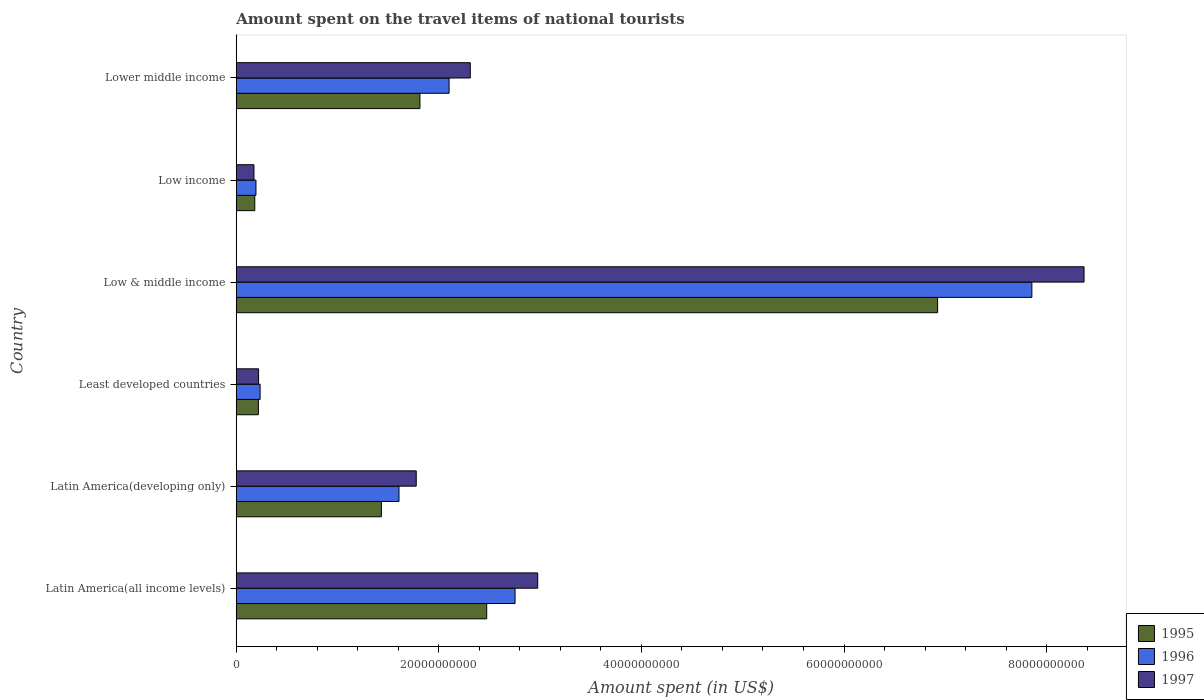Are the number of bars per tick equal to the number of legend labels?
Provide a succinct answer. Yes. Are the number of bars on each tick of the Y-axis equal?
Your answer should be compact. Yes. How many bars are there on the 6th tick from the top?
Provide a succinct answer. 3. How many bars are there on the 2nd tick from the bottom?
Your answer should be compact. 3. What is the label of the 1st group of bars from the top?
Your answer should be compact. Lower middle income. In how many cases, is the number of bars for a given country not equal to the number of legend labels?
Ensure brevity in your answer.  0. What is the amount spent on the travel items of national tourists in 1995 in Latin America(developing only)?
Ensure brevity in your answer.  1.43e+1. Across all countries, what is the maximum amount spent on the travel items of national tourists in 1996?
Provide a succinct answer. 7.85e+1. Across all countries, what is the minimum amount spent on the travel items of national tourists in 1996?
Provide a succinct answer. 1.94e+09. In which country was the amount spent on the travel items of national tourists in 1997 minimum?
Your answer should be compact. Low income. What is the total amount spent on the travel items of national tourists in 1996 in the graph?
Provide a short and direct response. 1.47e+11. What is the difference between the amount spent on the travel items of national tourists in 1995 in Latin America(developing only) and that in Lower middle income?
Make the answer very short. -3.81e+09. What is the difference between the amount spent on the travel items of national tourists in 1997 in Latin America(all income levels) and the amount spent on the travel items of national tourists in 1995 in Low & middle income?
Make the answer very short. -3.95e+1. What is the average amount spent on the travel items of national tourists in 1995 per country?
Give a very brief answer. 2.17e+1. What is the difference between the amount spent on the travel items of national tourists in 1996 and amount spent on the travel items of national tourists in 1995 in Low income?
Your answer should be compact. 1.15e+08. In how many countries, is the amount spent on the travel items of national tourists in 1995 greater than 24000000000 US$?
Your response must be concise. 2. What is the ratio of the amount spent on the travel items of national tourists in 1995 in Low & middle income to that in Lower middle income?
Your answer should be compact. 3.82. Is the amount spent on the travel items of national tourists in 1996 in Latin America(all income levels) less than that in Latin America(developing only)?
Give a very brief answer. No. What is the difference between the highest and the second highest amount spent on the travel items of national tourists in 1996?
Offer a terse response. 5.10e+1. What is the difference between the highest and the lowest amount spent on the travel items of national tourists in 1996?
Your answer should be compact. 7.66e+1. How many bars are there?
Your response must be concise. 18. Are the values on the major ticks of X-axis written in scientific E-notation?
Offer a very short reply. No. Does the graph contain any zero values?
Your answer should be very brief. No. How many legend labels are there?
Keep it short and to the point. 3. How are the legend labels stacked?
Provide a short and direct response. Vertical. What is the title of the graph?
Provide a short and direct response. Amount spent on the travel items of national tourists. Does "1979" appear as one of the legend labels in the graph?
Ensure brevity in your answer.  No. What is the label or title of the X-axis?
Your answer should be very brief. Amount spent (in US$). What is the Amount spent (in US$) in 1995 in Latin America(all income levels)?
Make the answer very short. 2.47e+1. What is the Amount spent (in US$) of 1996 in Latin America(all income levels)?
Provide a short and direct response. 2.75e+1. What is the Amount spent (in US$) of 1997 in Latin America(all income levels)?
Give a very brief answer. 2.98e+1. What is the Amount spent (in US$) in 1995 in Latin America(developing only)?
Offer a very short reply. 1.43e+1. What is the Amount spent (in US$) in 1996 in Latin America(developing only)?
Offer a very short reply. 1.61e+1. What is the Amount spent (in US$) of 1997 in Latin America(developing only)?
Your answer should be compact. 1.78e+1. What is the Amount spent (in US$) in 1995 in Least developed countries?
Offer a terse response. 2.19e+09. What is the Amount spent (in US$) in 1996 in Least developed countries?
Offer a terse response. 2.36e+09. What is the Amount spent (in US$) in 1997 in Least developed countries?
Ensure brevity in your answer.  2.20e+09. What is the Amount spent (in US$) of 1995 in Low & middle income?
Your answer should be very brief. 6.92e+1. What is the Amount spent (in US$) of 1996 in Low & middle income?
Your response must be concise. 7.85e+1. What is the Amount spent (in US$) in 1997 in Low & middle income?
Provide a succinct answer. 8.37e+1. What is the Amount spent (in US$) in 1995 in Low income?
Ensure brevity in your answer.  1.83e+09. What is the Amount spent (in US$) of 1996 in Low income?
Keep it short and to the point. 1.94e+09. What is the Amount spent (in US$) of 1997 in Low income?
Your answer should be very brief. 1.75e+09. What is the Amount spent (in US$) of 1995 in Lower middle income?
Make the answer very short. 1.81e+1. What is the Amount spent (in US$) in 1996 in Lower middle income?
Your response must be concise. 2.10e+1. What is the Amount spent (in US$) of 1997 in Lower middle income?
Your response must be concise. 2.31e+1. Across all countries, what is the maximum Amount spent (in US$) of 1995?
Provide a succinct answer. 6.92e+1. Across all countries, what is the maximum Amount spent (in US$) of 1996?
Give a very brief answer. 7.85e+1. Across all countries, what is the maximum Amount spent (in US$) of 1997?
Provide a short and direct response. 8.37e+1. Across all countries, what is the minimum Amount spent (in US$) in 1995?
Keep it short and to the point. 1.83e+09. Across all countries, what is the minimum Amount spent (in US$) in 1996?
Provide a succinct answer. 1.94e+09. Across all countries, what is the minimum Amount spent (in US$) of 1997?
Offer a terse response. 1.75e+09. What is the total Amount spent (in US$) of 1995 in the graph?
Your response must be concise. 1.30e+11. What is the total Amount spent (in US$) of 1996 in the graph?
Offer a very short reply. 1.47e+11. What is the total Amount spent (in US$) in 1997 in the graph?
Provide a succinct answer. 1.58e+11. What is the difference between the Amount spent (in US$) in 1995 in Latin America(all income levels) and that in Latin America(developing only)?
Offer a very short reply. 1.04e+1. What is the difference between the Amount spent (in US$) in 1996 in Latin America(all income levels) and that in Latin America(developing only)?
Make the answer very short. 1.15e+1. What is the difference between the Amount spent (in US$) of 1997 in Latin America(all income levels) and that in Latin America(developing only)?
Keep it short and to the point. 1.20e+1. What is the difference between the Amount spent (in US$) of 1995 in Latin America(all income levels) and that in Least developed countries?
Your answer should be very brief. 2.25e+1. What is the difference between the Amount spent (in US$) of 1996 in Latin America(all income levels) and that in Least developed countries?
Your answer should be very brief. 2.52e+1. What is the difference between the Amount spent (in US$) of 1997 in Latin America(all income levels) and that in Least developed countries?
Give a very brief answer. 2.76e+1. What is the difference between the Amount spent (in US$) in 1995 in Latin America(all income levels) and that in Low & middle income?
Ensure brevity in your answer.  -4.45e+1. What is the difference between the Amount spent (in US$) of 1996 in Latin America(all income levels) and that in Low & middle income?
Provide a short and direct response. -5.10e+1. What is the difference between the Amount spent (in US$) in 1997 in Latin America(all income levels) and that in Low & middle income?
Make the answer very short. -5.39e+1. What is the difference between the Amount spent (in US$) in 1995 in Latin America(all income levels) and that in Low income?
Give a very brief answer. 2.29e+1. What is the difference between the Amount spent (in US$) in 1996 in Latin America(all income levels) and that in Low income?
Offer a terse response. 2.56e+1. What is the difference between the Amount spent (in US$) of 1997 in Latin America(all income levels) and that in Low income?
Provide a succinct answer. 2.80e+1. What is the difference between the Amount spent (in US$) of 1995 in Latin America(all income levels) and that in Lower middle income?
Keep it short and to the point. 6.59e+09. What is the difference between the Amount spent (in US$) in 1996 in Latin America(all income levels) and that in Lower middle income?
Your answer should be very brief. 6.51e+09. What is the difference between the Amount spent (in US$) of 1997 in Latin America(all income levels) and that in Lower middle income?
Give a very brief answer. 6.66e+09. What is the difference between the Amount spent (in US$) in 1995 in Latin America(developing only) and that in Least developed countries?
Your response must be concise. 1.21e+1. What is the difference between the Amount spent (in US$) of 1996 in Latin America(developing only) and that in Least developed countries?
Provide a succinct answer. 1.37e+1. What is the difference between the Amount spent (in US$) in 1997 in Latin America(developing only) and that in Least developed countries?
Offer a very short reply. 1.56e+1. What is the difference between the Amount spent (in US$) of 1995 in Latin America(developing only) and that in Low & middle income?
Provide a short and direct response. -5.49e+1. What is the difference between the Amount spent (in US$) in 1996 in Latin America(developing only) and that in Low & middle income?
Offer a terse response. -6.25e+1. What is the difference between the Amount spent (in US$) in 1997 in Latin America(developing only) and that in Low & middle income?
Make the answer very short. -6.59e+1. What is the difference between the Amount spent (in US$) in 1995 in Latin America(developing only) and that in Low income?
Offer a very short reply. 1.25e+1. What is the difference between the Amount spent (in US$) of 1996 in Latin America(developing only) and that in Low income?
Your answer should be compact. 1.41e+1. What is the difference between the Amount spent (in US$) of 1997 in Latin America(developing only) and that in Low income?
Ensure brevity in your answer.  1.60e+1. What is the difference between the Amount spent (in US$) of 1995 in Latin America(developing only) and that in Lower middle income?
Provide a succinct answer. -3.81e+09. What is the difference between the Amount spent (in US$) of 1996 in Latin America(developing only) and that in Lower middle income?
Provide a short and direct response. -4.95e+09. What is the difference between the Amount spent (in US$) in 1997 in Latin America(developing only) and that in Lower middle income?
Make the answer very short. -5.34e+09. What is the difference between the Amount spent (in US$) in 1995 in Least developed countries and that in Low & middle income?
Your response must be concise. -6.71e+1. What is the difference between the Amount spent (in US$) of 1996 in Least developed countries and that in Low & middle income?
Give a very brief answer. -7.62e+1. What is the difference between the Amount spent (in US$) in 1997 in Least developed countries and that in Low & middle income?
Keep it short and to the point. -8.15e+1. What is the difference between the Amount spent (in US$) in 1995 in Least developed countries and that in Low income?
Make the answer very short. 3.56e+08. What is the difference between the Amount spent (in US$) of 1996 in Least developed countries and that in Low income?
Your answer should be very brief. 4.11e+08. What is the difference between the Amount spent (in US$) in 1997 in Least developed countries and that in Low income?
Your response must be concise. 4.55e+08. What is the difference between the Amount spent (in US$) of 1995 in Least developed countries and that in Lower middle income?
Offer a very short reply. -1.59e+1. What is the difference between the Amount spent (in US$) in 1996 in Least developed countries and that in Lower middle income?
Provide a succinct answer. -1.87e+1. What is the difference between the Amount spent (in US$) of 1997 in Least developed countries and that in Lower middle income?
Offer a very short reply. -2.09e+1. What is the difference between the Amount spent (in US$) of 1995 in Low & middle income and that in Low income?
Your answer should be very brief. 6.74e+1. What is the difference between the Amount spent (in US$) of 1996 in Low & middle income and that in Low income?
Provide a short and direct response. 7.66e+1. What is the difference between the Amount spent (in US$) of 1997 in Low & middle income and that in Low income?
Your answer should be very brief. 8.19e+1. What is the difference between the Amount spent (in US$) of 1995 in Low & middle income and that in Lower middle income?
Make the answer very short. 5.11e+1. What is the difference between the Amount spent (in US$) of 1996 in Low & middle income and that in Lower middle income?
Provide a short and direct response. 5.75e+1. What is the difference between the Amount spent (in US$) of 1997 in Low & middle income and that in Lower middle income?
Give a very brief answer. 6.06e+1. What is the difference between the Amount spent (in US$) of 1995 in Low income and that in Lower middle income?
Your response must be concise. -1.63e+1. What is the difference between the Amount spent (in US$) of 1996 in Low income and that in Lower middle income?
Keep it short and to the point. -1.91e+1. What is the difference between the Amount spent (in US$) of 1997 in Low income and that in Lower middle income?
Provide a succinct answer. -2.14e+1. What is the difference between the Amount spent (in US$) of 1995 in Latin America(all income levels) and the Amount spent (in US$) of 1996 in Latin America(developing only)?
Provide a succinct answer. 8.66e+09. What is the difference between the Amount spent (in US$) in 1995 in Latin America(all income levels) and the Amount spent (in US$) in 1997 in Latin America(developing only)?
Keep it short and to the point. 6.96e+09. What is the difference between the Amount spent (in US$) of 1996 in Latin America(all income levels) and the Amount spent (in US$) of 1997 in Latin America(developing only)?
Give a very brief answer. 9.76e+09. What is the difference between the Amount spent (in US$) in 1995 in Latin America(all income levels) and the Amount spent (in US$) in 1996 in Least developed countries?
Ensure brevity in your answer.  2.24e+1. What is the difference between the Amount spent (in US$) of 1995 in Latin America(all income levels) and the Amount spent (in US$) of 1997 in Least developed countries?
Give a very brief answer. 2.25e+1. What is the difference between the Amount spent (in US$) in 1996 in Latin America(all income levels) and the Amount spent (in US$) in 1997 in Least developed countries?
Make the answer very short. 2.53e+1. What is the difference between the Amount spent (in US$) of 1995 in Latin America(all income levels) and the Amount spent (in US$) of 1996 in Low & middle income?
Provide a succinct answer. -5.38e+1. What is the difference between the Amount spent (in US$) in 1995 in Latin America(all income levels) and the Amount spent (in US$) in 1997 in Low & middle income?
Offer a terse response. -5.90e+1. What is the difference between the Amount spent (in US$) in 1996 in Latin America(all income levels) and the Amount spent (in US$) in 1997 in Low & middle income?
Give a very brief answer. -5.62e+1. What is the difference between the Amount spent (in US$) of 1995 in Latin America(all income levels) and the Amount spent (in US$) of 1996 in Low income?
Make the answer very short. 2.28e+1. What is the difference between the Amount spent (in US$) in 1995 in Latin America(all income levels) and the Amount spent (in US$) in 1997 in Low income?
Give a very brief answer. 2.30e+1. What is the difference between the Amount spent (in US$) of 1996 in Latin America(all income levels) and the Amount spent (in US$) of 1997 in Low income?
Keep it short and to the point. 2.58e+1. What is the difference between the Amount spent (in US$) in 1995 in Latin America(all income levels) and the Amount spent (in US$) in 1996 in Lower middle income?
Ensure brevity in your answer.  3.71e+09. What is the difference between the Amount spent (in US$) in 1995 in Latin America(all income levels) and the Amount spent (in US$) in 1997 in Lower middle income?
Provide a succinct answer. 1.62e+09. What is the difference between the Amount spent (in US$) of 1996 in Latin America(all income levels) and the Amount spent (in US$) of 1997 in Lower middle income?
Provide a short and direct response. 4.42e+09. What is the difference between the Amount spent (in US$) of 1995 in Latin America(developing only) and the Amount spent (in US$) of 1996 in Least developed countries?
Provide a short and direct response. 1.20e+1. What is the difference between the Amount spent (in US$) in 1995 in Latin America(developing only) and the Amount spent (in US$) in 1997 in Least developed countries?
Your answer should be very brief. 1.21e+1. What is the difference between the Amount spent (in US$) in 1996 in Latin America(developing only) and the Amount spent (in US$) in 1997 in Least developed countries?
Your response must be concise. 1.39e+1. What is the difference between the Amount spent (in US$) in 1995 in Latin America(developing only) and the Amount spent (in US$) in 1996 in Low & middle income?
Your answer should be compact. -6.42e+1. What is the difference between the Amount spent (in US$) in 1995 in Latin America(developing only) and the Amount spent (in US$) in 1997 in Low & middle income?
Keep it short and to the point. -6.94e+1. What is the difference between the Amount spent (in US$) in 1996 in Latin America(developing only) and the Amount spent (in US$) in 1997 in Low & middle income?
Offer a terse response. -6.76e+1. What is the difference between the Amount spent (in US$) of 1995 in Latin America(developing only) and the Amount spent (in US$) of 1996 in Low income?
Keep it short and to the point. 1.24e+1. What is the difference between the Amount spent (in US$) of 1995 in Latin America(developing only) and the Amount spent (in US$) of 1997 in Low income?
Your answer should be very brief. 1.26e+1. What is the difference between the Amount spent (in US$) of 1996 in Latin America(developing only) and the Amount spent (in US$) of 1997 in Low income?
Your answer should be very brief. 1.43e+1. What is the difference between the Amount spent (in US$) in 1995 in Latin America(developing only) and the Amount spent (in US$) in 1996 in Lower middle income?
Your response must be concise. -6.69e+09. What is the difference between the Amount spent (in US$) of 1995 in Latin America(developing only) and the Amount spent (in US$) of 1997 in Lower middle income?
Ensure brevity in your answer.  -8.78e+09. What is the difference between the Amount spent (in US$) in 1996 in Latin America(developing only) and the Amount spent (in US$) in 1997 in Lower middle income?
Keep it short and to the point. -7.04e+09. What is the difference between the Amount spent (in US$) in 1995 in Least developed countries and the Amount spent (in US$) in 1996 in Low & middle income?
Provide a short and direct response. -7.64e+1. What is the difference between the Amount spent (in US$) in 1995 in Least developed countries and the Amount spent (in US$) in 1997 in Low & middle income?
Give a very brief answer. -8.15e+1. What is the difference between the Amount spent (in US$) in 1996 in Least developed countries and the Amount spent (in US$) in 1997 in Low & middle income?
Your answer should be very brief. -8.13e+1. What is the difference between the Amount spent (in US$) in 1995 in Least developed countries and the Amount spent (in US$) in 1996 in Low income?
Give a very brief answer. 2.41e+08. What is the difference between the Amount spent (in US$) of 1995 in Least developed countries and the Amount spent (in US$) of 1997 in Low income?
Provide a short and direct response. 4.37e+08. What is the difference between the Amount spent (in US$) in 1996 in Least developed countries and the Amount spent (in US$) in 1997 in Low income?
Your answer should be compact. 6.07e+08. What is the difference between the Amount spent (in US$) in 1995 in Least developed countries and the Amount spent (in US$) in 1996 in Lower middle income?
Offer a terse response. -1.88e+1. What is the difference between the Amount spent (in US$) of 1995 in Least developed countries and the Amount spent (in US$) of 1997 in Lower middle income?
Make the answer very short. -2.09e+1. What is the difference between the Amount spent (in US$) of 1996 in Least developed countries and the Amount spent (in US$) of 1997 in Lower middle income?
Keep it short and to the point. -2.07e+1. What is the difference between the Amount spent (in US$) in 1995 in Low & middle income and the Amount spent (in US$) in 1996 in Low income?
Your answer should be very brief. 6.73e+1. What is the difference between the Amount spent (in US$) in 1995 in Low & middle income and the Amount spent (in US$) in 1997 in Low income?
Your answer should be compact. 6.75e+1. What is the difference between the Amount spent (in US$) of 1996 in Low & middle income and the Amount spent (in US$) of 1997 in Low income?
Make the answer very short. 7.68e+1. What is the difference between the Amount spent (in US$) of 1995 in Low & middle income and the Amount spent (in US$) of 1996 in Lower middle income?
Your answer should be very brief. 4.82e+1. What is the difference between the Amount spent (in US$) in 1995 in Low & middle income and the Amount spent (in US$) in 1997 in Lower middle income?
Keep it short and to the point. 4.61e+1. What is the difference between the Amount spent (in US$) in 1996 in Low & middle income and the Amount spent (in US$) in 1997 in Lower middle income?
Your answer should be very brief. 5.54e+1. What is the difference between the Amount spent (in US$) in 1995 in Low income and the Amount spent (in US$) in 1996 in Lower middle income?
Your answer should be very brief. -1.92e+1. What is the difference between the Amount spent (in US$) in 1995 in Low income and the Amount spent (in US$) in 1997 in Lower middle income?
Give a very brief answer. -2.13e+1. What is the difference between the Amount spent (in US$) of 1996 in Low income and the Amount spent (in US$) of 1997 in Lower middle income?
Your answer should be compact. -2.12e+1. What is the average Amount spent (in US$) of 1995 per country?
Provide a succinct answer. 2.17e+1. What is the average Amount spent (in US$) in 1996 per country?
Ensure brevity in your answer.  2.46e+1. What is the average Amount spent (in US$) of 1997 per country?
Ensure brevity in your answer.  2.64e+1. What is the difference between the Amount spent (in US$) in 1995 and Amount spent (in US$) in 1996 in Latin America(all income levels)?
Keep it short and to the point. -2.80e+09. What is the difference between the Amount spent (in US$) in 1995 and Amount spent (in US$) in 1997 in Latin America(all income levels)?
Keep it short and to the point. -5.04e+09. What is the difference between the Amount spent (in US$) in 1996 and Amount spent (in US$) in 1997 in Latin America(all income levels)?
Offer a very short reply. -2.24e+09. What is the difference between the Amount spent (in US$) in 1995 and Amount spent (in US$) in 1996 in Latin America(developing only)?
Offer a very short reply. -1.74e+09. What is the difference between the Amount spent (in US$) of 1995 and Amount spent (in US$) of 1997 in Latin America(developing only)?
Your response must be concise. -3.44e+09. What is the difference between the Amount spent (in US$) in 1996 and Amount spent (in US$) in 1997 in Latin America(developing only)?
Offer a terse response. -1.70e+09. What is the difference between the Amount spent (in US$) of 1995 and Amount spent (in US$) of 1996 in Least developed countries?
Offer a very short reply. -1.70e+08. What is the difference between the Amount spent (in US$) in 1995 and Amount spent (in US$) in 1997 in Least developed countries?
Provide a succinct answer. -1.81e+07. What is the difference between the Amount spent (in US$) of 1996 and Amount spent (in US$) of 1997 in Least developed countries?
Make the answer very short. 1.52e+08. What is the difference between the Amount spent (in US$) of 1995 and Amount spent (in US$) of 1996 in Low & middle income?
Your answer should be very brief. -9.31e+09. What is the difference between the Amount spent (in US$) of 1995 and Amount spent (in US$) of 1997 in Low & middle income?
Give a very brief answer. -1.45e+1. What is the difference between the Amount spent (in US$) in 1996 and Amount spent (in US$) in 1997 in Low & middle income?
Provide a succinct answer. -5.15e+09. What is the difference between the Amount spent (in US$) of 1995 and Amount spent (in US$) of 1996 in Low income?
Your answer should be very brief. -1.15e+08. What is the difference between the Amount spent (in US$) in 1995 and Amount spent (in US$) in 1997 in Low income?
Your answer should be compact. 8.10e+07. What is the difference between the Amount spent (in US$) of 1996 and Amount spent (in US$) of 1997 in Low income?
Your response must be concise. 1.96e+08. What is the difference between the Amount spent (in US$) in 1995 and Amount spent (in US$) in 1996 in Lower middle income?
Your response must be concise. -2.88e+09. What is the difference between the Amount spent (in US$) of 1995 and Amount spent (in US$) of 1997 in Lower middle income?
Your answer should be compact. -4.97e+09. What is the difference between the Amount spent (in US$) of 1996 and Amount spent (in US$) of 1997 in Lower middle income?
Provide a short and direct response. -2.09e+09. What is the ratio of the Amount spent (in US$) in 1995 in Latin America(all income levels) to that in Latin America(developing only)?
Your answer should be very brief. 1.73. What is the ratio of the Amount spent (in US$) of 1996 in Latin America(all income levels) to that in Latin America(developing only)?
Give a very brief answer. 1.71. What is the ratio of the Amount spent (in US$) in 1997 in Latin America(all income levels) to that in Latin America(developing only)?
Keep it short and to the point. 1.68. What is the ratio of the Amount spent (in US$) of 1995 in Latin America(all income levels) to that in Least developed countries?
Give a very brief answer. 11.31. What is the ratio of the Amount spent (in US$) of 1996 in Latin America(all income levels) to that in Least developed countries?
Make the answer very short. 11.68. What is the ratio of the Amount spent (in US$) in 1997 in Latin America(all income levels) to that in Least developed countries?
Make the answer very short. 13.51. What is the ratio of the Amount spent (in US$) in 1995 in Latin America(all income levels) to that in Low & middle income?
Ensure brevity in your answer.  0.36. What is the ratio of the Amount spent (in US$) of 1996 in Latin America(all income levels) to that in Low & middle income?
Keep it short and to the point. 0.35. What is the ratio of the Amount spent (in US$) in 1997 in Latin America(all income levels) to that in Low & middle income?
Offer a very short reply. 0.36. What is the ratio of the Amount spent (in US$) of 1995 in Latin America(all income levels) to that in Low income?
Offer a very short reply. 13.51. What is the ratio of the Amount spent (in US$) of 1996 in Latin America(all income levels) to that in Low income?
Provide a succinct answer. 14.15. What is the ratio of the Amount spent (in US$) of 1997 in Latin America(all income levels) to that in Low income?
Offer a very short reply. 17.02. What is the ratio of the Amount spent (in US$) in 1995 in Latin America(all income levels) to that in Lower middle income?
Give a very brief answer. 1.36. What is the ratio of the Amount spent (in US$) in 1996 in Latin America(all income levels) to that in Lower middle income?
Offer a very short reply. 1.31. What is the ratio of the Amount spent (in US$) of 1997 in Latin America(all income levels) to that in Lower middle income?
Offer a terse response. 1.29. What is the ratio of the Amount spent (in US$) in 1995 in Latin America(developing only) to that in Least developed countries?
Your answer should be very brief. 6.56. What is the ratio of the Amount spent (in US$) in 1996 in Latin America(developing only) to that in Least developed countries?
Offer a terse response. 6.82. What is the ratio of the Amount spent (in US$) in 1997 in Latin America(developing only) to that in Least developed countries?
Your response must be concise. 8.06. What is the ratio of the Amount spent (in US$) in 1995 in Latin America(developing only) to that in Low & middle income?
Offer a terse response. 0.21. What is the ratio of the Amount spent (in US$) of 1996 in Latin America(developing only) to that in Low & middle income?
Offer a very short reply. 0.2. What is the ratio of the Amount spent (in US$) of 1997 in Latin America(developing only) to that in Low & middle income?
Provide a succinct answer. 0.21. What is the ratio of the Amount spent (in US$) of 1995 in Latin America(developing only) to that in Low income?
Offer a terse response. 7.83. What is the ratio of the Amount spent (in US$) in 1996 in Latin America(developing only) to that in Low income?
Your answer should be compact. 8.26. What is the ratio of the Amount spent (in US$) of 1997 in Latin America(developing only) to that in Low income?
Make the answer very short. 10.16. What is the ratio of the Amount spent (in US$) of 1995 in Latin America(developing only) to that in Lower middle income?
Ensure brevity in your answer.  0.79. What is the ratio of the Amount spent (in US$) of 1996 in Latin America(developing only) to that in Lower middle income?
Ensure brevity in your answer.  0.76. What is the ratio of the Amount spent (in US$) of 1997 in Latin America(developing only) to that in Lower middle income?
Make the answer very short. 0.77. What is the ratio of the Amount spent (in US$) in 1995 in Least developed countries to that in Low & middle income?
Keep it short and to the point. 0.03. What is the ratio of the Amount spent (in US$) of 1997 in Least developed countries to that in Low & middle income?
Provide a short and direct response. 0.03. What is the ratio of the Amount spent (in US$) in 1995 in Least developed countries to that in Low income?
Offer a very short reply. 1.19. What is the ratio of the Amount spent (in US$) of 1996 in Least developed countries to that in Low income?
Make the answer very short. 1.21. What is the ratio of the Amount spent (in US$) in 1997 in Least developed countries to that in Low income?
Keep it short and to the point. 1.26. What is the ratio of the Amount spent (in US$) of 1995 in Least developed countries to that in Lower middle income?
Keep it short and to the point. 0.12. What is the ratio of the Amount spent (in US$) in 1996 in Least developed countries to that in Lower middle income?
Offer a terse response. 0.11. What is the ratio of the Amount spent (in US$) in 1997 in Least developed countries to that in Lower middle income?
Provide a succinct answer. 0.1. What is the ratio of the Amount spent (in US$) in 1995 in Low & middle income to that in Low income?
Offer a very short reply. 37.85. What is the ratio of the Amount spent (in US$) of 1996 in Low & middle income to that in Low income?
Offer a terse response. 40.39. What is the ratio of the Amount spent (in US$) in 1997 in Low & middle income to that in Low income?
Offer a terse response. 47.87. What is the ratio of the Amount spent (in US$) of 1995 in Low & middle income to that in Lower middle income?
Offer a very short reply. 3.82. What is the ratio of the Amount spent (in US$) in 1996 in Low & middle income to that in Lower middle income?
Give a very brief answer. 3.74. What is the ratio of the Amount spent (in US$) in 1997 in Low & middle income to that in Lower middle income?
Your answer should be very brief. 3.62. What is the ratio of the Amount spent (in US$) in 1995 in Low income to that in Lower middle income?
Provide a short and direct response. 0.1. What is the ratio of the Amount spent (in US$) of 1996 in Low income to that in Lower middle income?
Provide a succinct answer. 0.09. What is the ratio of the Amount spent (in US$) in 1997 in Low income to that in Lower middle income?
Provide a short and direct response. 0.08. What is the difference between the highest and the second highest Amount spent (in US$) in 1995?
Your answer should be very brief. 4.45e+1. What is the difference between the highest and the second highest Amount spent (in US$) in 1996?
Give a very brief answer. 5.10e+1. What is the difference between the highest and the second highest Amount spent (in US$) in 1997?
Make the answer very short. 5.39e+1. What is the difference between the highest and the lowest Amount spent (in US$) in 1995?
Your response must be concise. 6.74e+1. What is the difference between the highest and the lowest Amount spent (in US$) of 1996?
Keep it short and to the point. 7.66e+1. What is the difference between the highest and the lowest Amount spent (in US$) in 1997?
Keep it short and to the point. 8.19e+1. 